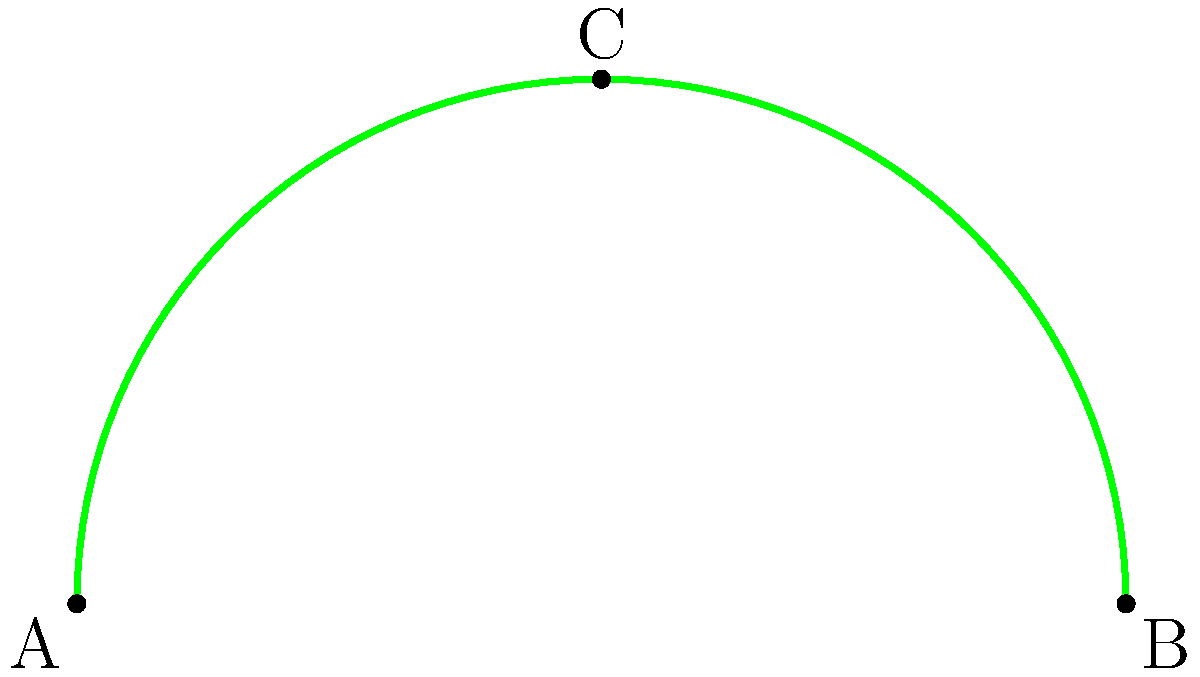In your latest brand emblem design, you've created an irregular shape formed by two vector curves. The shape is symmetrical, with point A at (0,0), point B at (2,0), and point C at (1,1). The blue curve goes from A to B through C, while the green curve goes from B to A through C. Both curves are smooth and continuous. Estimate the area of this shape using numerical integration methods. Round your answer to two decimal places. To estimate the area of this irregular shape, we can use numerical integration methods. Here's a step-by-step approach:

1) First, we need to define the functions for the upper and lower curves. Given the symmetry, we can focus on half of the shape (from x=0 to x=1) and double the result.

2) For the upper curve (blue), we can approximate it with a quadratic function:
   $$f(x) = ax^2 + bx + c$$
   Given that it passes through (0,0), (0.5,0.5), and (1,1), we can solve for a, b, and c:
   $$f(x) = x^2$$

3) For the lower curve (green), we can use a similar approach:
   $$g(x) = -x^2 + 2x$$

4) The area can be calculated by integrating the difference between these functions:
   $$Area = 2 \int_0^1 (f(x) - g(x)) dx$$

5) Substituting our functions:
   $$Area = 2 \int_0^1 (x^2 - (-x^2 + 2x)) dx$$
   $$     = 2 \int_0^1 (2x^2 - 2x) dx$$

6) Integrating:
   $$Area = 2 [\frac{2x^3}{3} - x^2]_0^1$$
   $$     = 2 [(\frac{2}{3} - 1) - (0 - 0)]$$
   $$     = 2 (\frac{-1}{3})$$
   $$     = \frac{-2}{3}$$

7) Taking the absolute value and rounding to two decimal places:
   $$Area \approx 0.67$$

Therefore, the estimated area of the irregular shape is approximately 0.67 square units.
Answer: 0.67 square units 